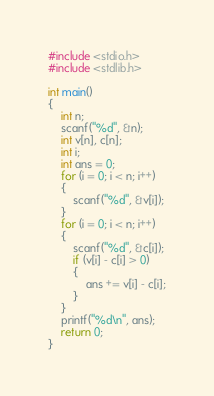<code> <loc_0><loc_0><loc_500><loc_500><_C_>#include <stdio.h>
#include <stdlib.h>

int main()
{
    int n;
    scanf("%d", &n);
    int v[n], c[n];
    int i;
    int ans = 0;
    for (i = 0; i < n; i++)
    {
        scanf("%d", &v[i]);
    }
    for (i = 0; i < n; i++)
    {
        scanf("%d", &c[i]);
        if (v[i] - c[i] > 0)
        {
            ans += v[i] - c[i];
        }
    }
    printf("%d\n", ans);
    return 0;
}	</code> 